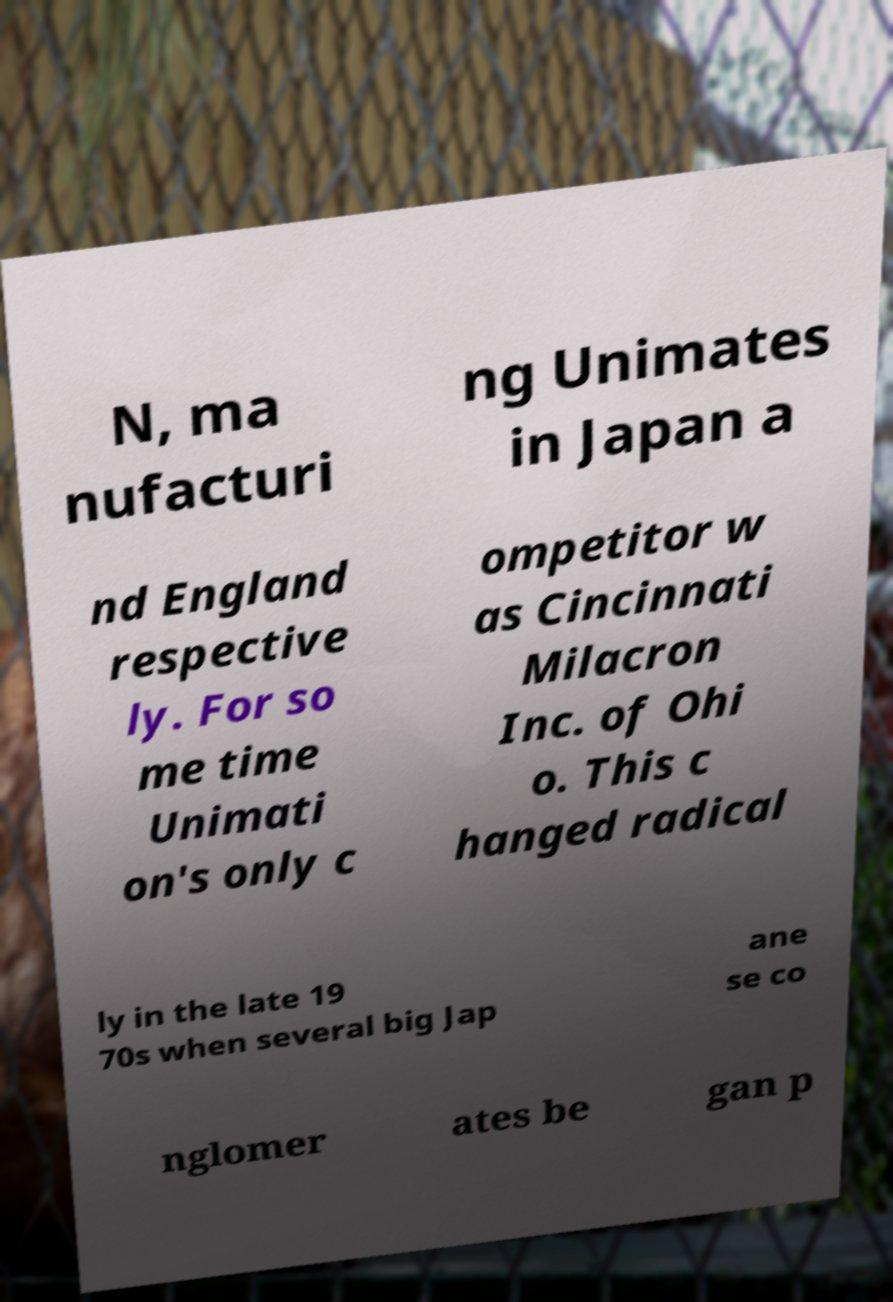For documentation purposes, I need the text within this image transcribed. Could you provide that? N, ma nufacturi ng Unimates in Japan a nd England respective ly. For so me time Unimati on's only c ompetitor w as Cincinnati Milacron Inc. of Ohi o. This c hanged radical ly in the late 19 70s when several big Jap ane se co nglomer ates be gan p 